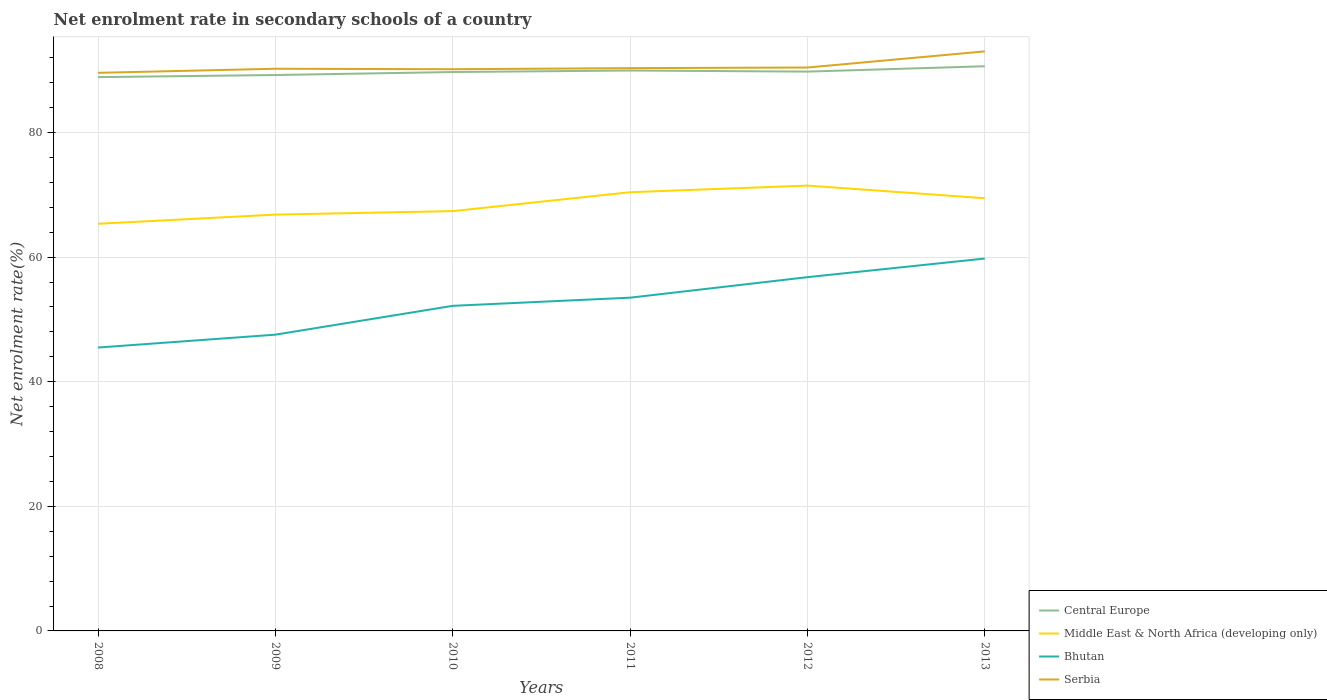Is the number of lines equal to the number of legend labels?
Your response must be concise. Yes. Across all years, what is the maximum net enrolment rate in secondary schools in Serbia?
Make the answer very short. 89.59. What is the total net enrolment rate in secondary schools in Serbia in the graph?
Offer a terse response. -0.58. What is the difference between the highest and the second highest net enrolment rate in secondary schools in Bhutan?
Your answer should be very brief. 14.29. Is the net enrolment rate in secondary schools in Middle East & North Africa (developing only) strictly greater than the net enrolment rate in secondary schools in Central Europe over the years?
Keep it short and to the point. Yes. How many years are there in the graph?
Give a very brief answer. 6. Are the values on the major ticks of Y-axis written in scientific E-notation?
Provide a succinct answer. No. Does the graph contain any zero values?
Make the answer very short. No. Does the graph contain grids?
Your answer should be very brief. Yes. Where does the legend appear in the graph?
Make the answer very short. Bottom right. How many legend labels are there?
Ensure brevity in your answer.  4. What is the title of the graph?
Your response must be concise. Net enrolment rate in secondary schools of a country. Does "Sao Tome and Principe" appear as one of the legend labels in the graph?
Make the answer very short. No. What is the label or title of the Y-axis?
Offer a terse response. Net enrolment rate(%). What is the Net enrolment rate(%) of Central Europe in 2008?
Give a very brief answer. 88.9. What is the Net enrolment rate(%) in Middle East & North Africa (developing only) in 2008?
Offer a very short reply. 65.36. What is the Net enrolment rate(%) in Bhutan in 2008?
Make the answer very short. 45.49. What is the Net enrolment rate(%) of Serbia in 2008?
Offer a terse response. 89.59. What is the Net enrolment rate(%) of Central Europe in 2009?
Provide a succinct answer. 89.23. What is the Net enrolment rate(%) of Middle East & North Africa (developing only) in 2009?
Make the answer very short. 66.83. What is the Net enrolment rate(%) in Bhutan in 2009?
Offer a terse response. 47.56. What is the Net enrolment rate(%) of Serbia in 2009?
Your answer should be very brief. 90.24. What is the Net enrolment rate(%) of Central Europe in 2010?
Provide a short and direct response. 89.71. What is the Net enrolment rate(%) of Middle East & North Africa (developing only) in 2010?
Make the answer very short. 67.39. What is the Net enrolment rate(%) of Bhutan in 2010?
Your answer should be compact. 52.19. What is the Net enrolment rate(%) in Serbia in 2010?
Offer a very short reply. 90.17. What is the Net enrolment rate(%) in Central Europe in 2011?
Ensure brevity in your answer.  89.96. What is the Net enrolment rate(%) in Middle East & North Africa (developing only) in 2011?
Your answer should be compact. 70.42. What is the Net enrolment rate(%) of Bhutan in 2011?
Keep it short and to the point. 53.49. What is the Net enrolment rate(%) of Serbia in 2011?
Ensure brevity in your answer.  90.34. What is the Net enrolment rate(%) in Central Europe in 2012?
Offer a terse response. 89.78. What is the Net enrolment rate(%) of Middle East & North Africa (developing only) in 2012?
Offer a terse response. 71.49. What is the Net enrolment rate(%) of Bhutan in 2012?
Offer a terse response. 56.79. What is the Net enrolment rate(%) of Serbia in 2012?
Give a very brief answer. 90.44. What is the Net enrolment rate(%) of Central Europe in 2013?
Provide a succinct answer. 90.64. What is the Net enrolment rate(%) of Middle East & North Africa (developing only) in 2013?
Make the answer very short. 69.46. What is the Net enrolment rate(%) of Bhutan in 2013?
Your response must be concise. 59.78. What is the Net enrolment rate(%) in Serbia in 2013?
Your response must be concise. 93.03. Across all years, what is the maximum Net enrolment rate(%) in Central Europe?
Ensure brevity in your answer.  90.64. Across all years, what is the maximum Net enrolment rate(%) in Middle East & North Africa (developing only)?
Offer a very short reply. 71.49. Across all years, what is the maximum Net enrolment rate(%) in Bhutan?
Offer a very short reply. 59.78. Across all years, what is the maximum Net enrolment rate(%) of Serbia?
Make the answer very short. 93.03. Across all years, what is the minimum Net enrolment rate(%) in Central Europe?
Ensure brevity in your answer.  88.9. Across all years, what is the minimum Net enrolment rate(%) in Middle East & North Africa (developing only)?
Your response must be concise. 65.36. Across all years, what is the minimum Net enrolment rate(%) in Bhutan?
Your response must be concise. 45.49. Across all years, what is the minimum Net enrolment rate(%) in Serbia?
Offer a terse response. 89.59. What is the total Net enrolment rate(%) in Central Europe in the graph?
Provide a short and direct response. 538.23. What is the total Net enrolment rate(%) in Middle East & North Africa (developing only) in the graph?
Ensure brevity in your answer.  410.94. What is the total Net enrolment rate(%) in Bhutan in the graph?
Keep it short and to the point. 315.29. What is the total Net enrolment rate(%) of Serbia in the graph?
Make the answer very short. 543.8. What is the difference between the Net enrolment rate(%) of Central Europe in 2008 and that in 2009?
Ensure brevity in your answer.  -0.34. What is the difference between the Net enrolment rate(%) in Middle East & North Africa (developing only) in 2008 and that in 2009?
Provide a succinct answer. -1.47. What is the difference between the Net enrolment rate(%) of Bhutan in 2008 and that in 2009?
Provide a succinct answer. -2.07. What is the difference between the Net enrolment rate(%) of Serbia in 2008 and that in 2009?
Provide a short and direct response. -0.65. What is the difference between the Net enrolment rate(%) of Central Europe in 2008 and that in 2010?
Your response must be concise. -0.82. What is the difference between the Net enrolment rate(%) of Middle East & North Africa (developing only) in 2008 and that in 2010?
Give a very brief answer. -2.03. What is the difference between the Net enrolment rate(%) in Bhutan in 2008 and that in 2010?
Your response must be concise. -6.7. What is the difference between the Net enrolment rate(%) of Serbia in 2008 and that in 2010?
Give a very brief answer. -0.58. What is the difference between the Net enrolment rate(%) in Central Europe in 2008 and that in 2011?
Offer a very short reply. -1.06. What is the difference between the Net enrolment rate(%) in Middle East & North Africa (developing only) in 2008 and that in 2011?
Give a very brief answer. -5.07. What is the difference between the Net enrolment rate(%) in Bhutan in 2008 and that in 2011?
Offer a very short reply. -8. What is the difference between the Net enrolment rate(%) in Serbia in 2008 and that in 2011?
Make the answer very short. -0.75. What is the difference between the Net enrolment rate(%) of Central Europe in 2008 and that in 2012?
Your answer should be compact. -0.89. What is the difference between the Net enrolment rate(%) in Middle East & North Africa (developing only) in 2008 and that in 2012?
Ensure brevity in your answer.  -6.13. What is the difference between the Net enrolment rate(%) of Bhutan in 2008 and that in 2012?
Provide a short and direct response. -11.3. What is the difference between the Net enrolment rate(%) in Serbia in 2008 and that in 2012?
Keep it short and to the point. -0.85. What is the difference between the Net enrolment rate(%) in Central Europe in 2008 and that in 2013?
Offer a very short reply. -1.75. What is the difference between the Net enrolment rate(%) of Middle East & North Africa (developing only) in 2008 and that in 2013?
Provide a short and direct response. -4.1. What is the difference between the Net enrolment rate(%) in Bhutan in 2008 and that in 2013?
Your response must be concise. -14.29. What is the difference between the Net enrolment rate(%) in Serbia in 2008 and that in 2013?
Make the answer very short. -3.44. What is the difference between the Net enrolment rate(%) of Central Europe in 2009 and that in 2010?
Your answer should be very brief. -0.48. What is the difference between the Net enrolment rate(%) of Middle East & North Africa (developing only) in 2009 and that in 2010?
Ensure brevity in your answer.  -0.56. What is the difference between the Net enrolment rate(%) in Bhutan in 2009 and that in 2010?
Give a very brief answer. -4.63. What is the difference between the Net enrolment rate(%) in Serbia in 2009 and that in 2010?
Keep it short and to the point. 0.07. What is the difference between the Net enrolment rate(%) of Central Europe in 2009 and that in 2011?
Provide a succinct answer. -0.72. What is the difference between the Net enrolment rate(%) in Middle East & North Africa (developing only) in 2009 and that in 2011?
Your answer should be very brief. -3.6. What is the difference between the Net enrolment rate(%) in Bhutan in 2009 and that in 2011?
Offer a very short reply. -5.94. What is the difference between the Net enrolment rate(%) in Serbia in 2009 and that in 2011?
Ensure brevity in your answer.  -0.1. What is the difference between the Net enrolment rate(%) in Central Europe in 2009 and that in 2012?
Your response must be concise. -0.55. What is the difference between the Net enrolment rate(%) in Middle East & North Africa (developing only) in 2009 and that in 2012?
Ensure brevity in your answer.  -4.66. What is the difference between the Net enrolment rate(%) in Bhutan in 2009 and that in 2012?
Make the answer very short. -9.23. What is the difference between the Net enrolment rate(%) in Serbia in 2009 and that in 2012?
Your response must be concise. -0.2. What is the difference between the Net enrolment rate(%) in Central Europe in 2009 and that in 2013?
Your answer should be very brief. -1.41. What is the difference between the Net enrolment rate(%) in Middle East & North Africa (developing only) in 2009 and that in 2013?
Make the answer very short. -2.63. What is the difference between the Net enrolment rate(%) in Bhutan in 2009 and that in 2013?
Make the answer very short. -12.22. What is the difference between the Net enrolment rate(%) in Serbia in 2009 and that in 2013?
Make the answer very short. -2.79. What is the difference between the Net enrolment rate(%) in Central Europe in 2010 and that in 2011?
Your response must be concise. -0.24. What is the difference between the Net enrolment rate(%) in Middle East & North Africa (developing only) in 2010 and that in 2011?
Provide a short and direct response. -3.03. What is the difference between the Net enrolment rate(%) of Bhutan in 2010 and that in 2011?
Your answer should be very brief. -1.31. What is the difference between the Net enrolment rate(%) of Serbia in 2010 and that in 2011?
Provide a short and direct response. -0.17. What is the difference between the Net enrolment rate(%) in Central Europe in 2010 and that in 2012?
Provide a short and direct response. -0.07. What is the difference between the Net enrolment rate(%) of Middle East & North Africa (developing only) in 2010 and that in 2012?
Give a very brief answer. -4.1. What is the difference between the Net enrolment rate(%) in Bhutan in 2010 and that in 2012?
Provide a short and direct response. -4.6. What is the difference between the Net enrolment rate(%) of Serbia in 2010 and that in 2012?
Your answer should be very brief. -0.27. What is the difference between the Net enrolment rate(%) in Central Europe in 2010 and that in 2013?
Your response must be concise. -0.93. What is the difference between the Net enrolment rate(%) in Middle East & North Africa (developing only) in 2010 and that in 2013?
Offer a terse response. -2.07. What is the difference between the Net enrolment rate(%) of Bhutan in 2010 and that in 2013?
Your answer should be very brief. -7.59. What is the difference between the Net enrolment rate(%) in Serbia in 2010 and that in 2013?
Make the answer very short. -2.86. What is the difference between the Net enrolment rate(%) in Central Europe in 2011 and that in 2012?
Keep it short and to the point. 0.18. What is the difference between the Net enrolment rate(%) in Middle East & North Africa (developing only) in 2011 and that in 2012?
Provide a short and direct response. -1.07. What is the difference between the Net enrolment rate(%) in Bhutan in 2011 and that in 2012?
Your response must be concise. -3.29. What is the difference between the Net enrolment rate(%) in Central Europe in 2011 and that in 2013?
Your answer should be compact. -0.68. What is the difference between the Net enrolment rate(%) in Bhutan in 2011 and that in 2013?
Make the answer very short. -6.28. What is the difference between the Net enrolment rate(%) in Serbia in 2011 and that in 2013?
Provide a short and direct response. -2.69. What is the difference between the Net enrolment rate(%) in Central Europe in 2012 and that in 2013?
Offer a terse response. -0.86. What is the difference between the Net enrolment rate(%) in Middle East & North Africa (developing only) in 2012 and that in 2013?
Keep it short and to the point. 2.03. What is the difference between the Net enrolment rate(%) in Bhutan in 2012 and that in 2013?
Your answer should be compact. -2.99. What is the difference between the Net enrolment rate(%) in Serbia in 2012 and that in 2013?
Offer a terse response. -2.59. What is the difference between the Net enrolment rate(%) of Central Europe in 2008 and the Net enrolment rate(%) of Middle East & North Africa (developing only) in 2009?
Ensure brevity in your answer.  22.07. What is the difference between the Net enrolment rate(%) in Central Europe in 2008 and the Net enrolment rate(%) in Bhutan in 2009?
Give a very brief answer. 41.34. What is the difference between the Net enrolment rate(%) of Central Europe in 2008 and the Net enrolment rate(%) of Serbia in 2009?
Keep it short and to the point. -1.35. What is the difference between the Net enrolment rate(%) of Middle East & North Africa (developing only) in 2008 and the Net enrolment rate(%) of Bhutan in 2009?
Ensure brevity in your answer.  17.8. What is the difference between the Net enrolment rate(%) in Middle East & North Africa (developing only) in 2008 and the Net enrolment rate(%) in Serbia in 2009?
Provide a succinct answer. -24.89. What is the difference between the Net enrolment rate(%) of Bhutan in 2008 and the Net enrolment rate(%) of Serbia in 2009?
Ensure brevity in your answer.  -44.75. What is the difference between the Net enrolment rate(%) of Central Europe in 2008 and the Net enrolment rate(%) of Middle East & North Africa (developing only) in 2010?
Keep it short and to the point. 21.51. What is the difference between the Net enrolment rate(%) in Central Europe in 2008 and the Net enrolment rate(%) in Bhutan in 2010?
Keep it short and to the point. 36.71. What is the difference between the Net enrolment rate(%) in Central Europe in 2008 and the Net enrolment rate(%) in Serbia in 2010?
Give a very brief answer. -1.27. What is the difference between the Net enrolment rate(%) in Middle East & North Africa (developing only) in 2008 and the Net enrolment rate(%) in Bhutan in 2010?
Offer a terse response. 13.17. What is the difference between the Net enrolment rate(%) in Middle East & North Africa (developing only) in 2008 and the Net enrolment rate(%) in Serbia in 2010?
Offer a very short reply. -24.81. What is the difference between the Net enrolment rate(%) in Bhutan in 2008 and the Net enrolment rate(%) in Serbia in 2010?
Your answer should be compact. -44.68. What is the difference between the Net enrolment rate(%) in Central Europe in 2008 and the Net enrolment rate(%) in Middle East & North Africa (developing only) in 2011?
Your answer should be compact. 18.47. What is the difference between the Net enrolment rate(%) of Central Europe in 2008 and the Net enrolment rate(%) of Bhutan in 2011?
Make the answer very short. 35.4. What is the difference between the Net enrolment rate(%) of Central Europe in 2008 and the Net enrolment rate(%) of Serbia in 2011?
Provide a short and direct response. -1.44. What is the difference between the Net enrolment rate(%) of Middle East & North Africa (developing only) in 2008 and the Net enrolment rate(%) of Bhutan in 2011?
Your response must be concise. 11.86. What is the difference between the Net enrolment rate(%) in Middle East & North Africa (developing only) in 2008 and the Net enrolment rate(%) in Serbia in 2011?
Ensure brevity in your answer.  -24.98. What is the difference between the Net enrolment rate(%) of Bhutan in 2008 and the Net enrolment rate(%) of Serbia in 2011?
Give a very brief answer. -44.85. What is the difference between the Net enrolment rate(%) in Central Europe in 2008 and the Net enrolment rate(%) in Middle East & North Africa (developing only) in 2012?
Provide a short and direct response. 17.41. What is the difference between the Net enrolment rate(%) of Central Europe in 2008 and the Net enrolment rate(%) of Bhutan in 2012?
Your answer should be compact. 32.11. What is the difference between the Net enrolment rate(%) in Central Europe in 2008 and the Net enrolment rate(%) in Serbia in 2012?
Provide a succinct answer. -1.54. What is the difference between the Net enrolment rate(%) of Middle East & North Africa (developing only) in 2008 and the Net enrolment rate(%) of Bhutan in 2012?
Provide a succinct answer. 8.57. What is the difference between the Net enrolment rate(%) in Middle East & North Africa (developing only) in 2008 and the Net enrolment rate(%) in Serbia in 2012?
Provide a short and direct response. -25.08. What is the difference between the Net enrolment rate(%) in Bhutan in 2008 and the Net enrolment rate(%) in Serbia in 2012?
Keep it short and to the point. -44.95. What is the difference between the Net enrolment rate(%) in Central Europe in 2008 and the Net enrolment rate(%) in Middle East & North Africa (developing only) in 2013?
Your answer should be compact. 19.44. What is the difference between the Net enrolment rate(%) in Central Europe in 2008 and the Net enrolment rate(%) in Bhutan in 2013?
Offer a terse response. 29.12. What is the difference between the Net enrolment rate(%) of Central Europe in 2008 and the Net enrolment rate(%) of Serbia in 2013?
Your answer should be compact. -4.13. What is the difference between the Net enrolment rate(%) of Middle East & North Africa (developing only) in 2008 and the Net enrolment rate(%) of Bhutan in 2013?
Offer a very short reply. 5.58. What is the difference between the Net enrolment rate(%) in Middle East & North Africa (developing only) in 2008 and the Net enrolment rate(%) in Serbia in 2013?
Offer a terse response. -27.67. What is the difference between the Net enrolment rate(%) of Bhutan in 2008 and the Net enrolment rate(%) of Serbia in 2013?
Make the answer very short. -47.54. What is the difference between the Net enrolment rate(%) in Central Europe in 2009 and the Net enrolment rate(%) in Middle East & North Africa (developing only) in 2010?
Provide a succinct answer. 21.85. What is the difference between the Net enrolment rate(%) of Central Europe in 2009 and the Net enrolment rate(%) of Bhutan in 2010?
Make the answer very short. 37.05. What is the difference between the Net enrolment rate(%) in Central Europe in 2009 and the Net enrolment rate(%) in Serbia in 2010?
Your answer should be compact. -0.93. What is the difference between the Net enrolment rate(%) of Middle East & North Africa (developing only) in 2009 and the Net enrolment rate(%) of Bhutan in 2010?
Ensure brevity in your answer.  14.64. What is the difference between the Net enrolment rate(%) of Middle East & North Africa (developing only) in 2009 and the Net enrolment rate(%) of Serbia in 2010?
Provide a succinct answer. -23.34. What is the difference between the Net enrolment rate(%) in Bhutan in 2009 and the Net enrolment rate(%) in Serbia in 2010?
Provide a short and direct response. -42.61. What is the difference between the Net enrolment rate(%) of Central Europe in 2009 and the Net enrolment rate(%) of Middle East & North Africa (developing only) in 2011?
Give a very brief answer. 18.81. What is the difference between the Net enrolment rate(%) in Central Europe in 2009 and the Net enrolment rate(%) in Bhutan in 2011?
Provide a short and direct response. 35.74. What is the difference between the Net enrolment rate(%) in Central Europe in 2009 and the Net enrolment rate(%) in Serbia in 2011?
Ensure brevity in your answer.  -1.1. What is the difference between the Net enrolment rate(%) in Middle East & North Africa (developing only) in 2009 and the Net enrolment rate(%) in Bhutan in 2011?
Make the answer very short. 13.33. What is the difference between the Net enrolment rate(%) in Middle East & North Africa (developing only) in 2009 and the Net enrolment rate(%) in Serbia in 2011?
Give a very brief answer. -23.51. What is the difference between the Net enrolment rate(%) in Bhutan in 2009 and the Net enrolment rate(%) in Serbia in 2011?
Provide a short and direct response. -42.78. What is the difference between the Net enrolment rate(%) of Central Europe in 2009 and the Net enrolment rate(%) of Middle East & North Africa (developing only) in 2012?
Your answer should be very brief. 17.75. What is the difference between the Net enrolment rate(%) of Central Europe in 2009 and the Net enrolment rate(%) of Bhutan in 2012?
Make the answer very short. 32.45. What is the difference between the Net enrolment rate(%) in Central Europe in 2009 and the Net enrolment rate(%) in Serbia in 2012?
Offer a very short reply. -1.2. What is the difference between the Net enrolment rate(%) in Middle East & North Africa (developing only) in 2009 and the Net enrolment rate(%) in Bhutan in 2012?
Your answer should be compact. 10.04. What is the difference between the Net enrolment rate(%) in Middle East & North Africa (developing only) in 2009 and the Net enrolment rate(%) in Serbia in 2012?
Provide a short and direct response. -23.61. What is the difference between the Net enrolment rate(%) of Bhutan in 2009 and the Net enrolment rate(%) of Serbia in 2012?
Your response must be concise. -42.88. What is the difference between the Net enrolment rate(%) of Central Europe in 2009 and the Net enrolment rate(%) of Middle East & North Africa (developing only) in 2013?
Your answer should be compact. 19.78. What is the difference between the Net enrolment rate(%) of Central Europe in 2009 and the Net enrolment rate(%) of Bhutan in 2013?
Your answer should be very brief. 29.46. What is the difference between the Net enrolment rate(%) of Central Europe in 2009 and the Net enrolment rate(%) of Serbia in 2013?
Make the answer very short. -3.79. What is the difference between the Net enrolment rate(%) in Middle East & North Africa (developing only) in 2009 and the Net enrolment rate(%) in Bhutan in 2013?
Offer a very short reply. 7.05. What is the difference between the Net enrolment rate(%) in Middle East & North Africa (developing only) in 2009 and the Net enrolment rate(%) in Serbia in 2013?
Your answer should be very brief. -26.2. What is the difference between the Net enrolment rate(%) of Bhutan in 2009 and the Net enrolment rate(%) of Serbia in 2013?
Offer a very short reply. -45.47. What is the difference between the Net enrolment rate(%) of Central Europe in 2010 and the Net enrolment rate(%) of Middle East & North Africa (developing only) in 2011?
Ensure brevity in your answer.  19.29. What is the difference between the Net enrolment rate(%) of Central Europe in 2010 and the Net enrolment rate(%) of Bhutan in 2011?
Your answer should be very brief. 36.22. What is the difference between the Net enrolment rate(%) of Central Europe in 2010 and the Net enrolment rate(%) of Serbia in 2011?
Provide a short and direct response. -0.62. What is the difference between the Net enrolment rate(%) of Middle East & North Africa (developing only) in 2010 and the Net enrolment rate(%) of Bhutan in 2011?
Give a very brief answer. 13.89. What is the difference between the Net enrolment rate(%) of Middle East & North Africa (developing only) in 2010 and the Net enrolment rate(%) of Serbia in 2011?
Your response must be concise. -22.95. What is the difference between the Net enrolment rate(%) in Bhutan in 2010 and the Net enrolment rate(%) in Serbia in 2011?
Keep it short and to the point. -38.15. What is the difference between the Net enrolment rate(%) in Central Europe in 2010 and the Net enrolment rate(%) in Middle East & North Africa (developing only) in 2012?
Your answer should be very brief. 18.23. What is the difference between the Net enrolment rate(%) in Central Europe in 2010 and the Net enrolment rate(%) in Bhutan in 2012?
Provide a succinct answer. 32.93. What is the difference between the Net enrolment rate(%) of Central Europe in 2010 and the Net enrolment rate(%) of Serbia in 2012?
Provide a short and direct response. -0.72. What is the difference between the Net enrolment rate(%) in Middle East & North Africa (developing only) in 2010 and the Net enrolment rate(%) in Bhutan in 2012?
Keep it short and to the point. 10.6. What is the difference between the Net enrolment rate(%) in Middle East & North Africa (developing only) in 2010 and the Net enrolment rate(%) in Serbia in 2012?
Ensure brevity in your answer.  -23.05. What is the difference between the Net enrolment rate(%) in Bhutan in 2010 and the Net enrolment rate(%) in Serbia in 2012?
Provide a succinct answer. -38.25. What is the difference between the Net enrolment rate(%) of Central Europe in 2010 and the Net enrolment rate(%) of Middle East & North Africa (developing only) in 2013?
Provide a short and direct response. 20.26. What is the difference between the Net enrolment rate(%) of Central Europe in 2010 and the Net enrolment rate(%) of Bhutan in 2013?
Make the answer very short. 29.94. What is the difference between the Net enrolment rate(%) of Central Europe in 2010 and the Net enrolment rate(%) of Serbia in 2013?
Give a very brief answer. -3.31. What is the difference between the Net enrolment rate(%) of Middle East & North Africa (developing only) in 2010 and the Net enrolment rate(%) of Bhutan in 2013?
Ensure brevity in your answer.  7.61. What is the difference between the Net enrolment rate(%) of Middle East & North Africa (developing only) in 2010 and the Net enrolment rate(%) of Serbia in 2013?
Your answer should be very brief. -25.64. What is the difference between the Net enrolment rate(%) of Bhutan in 2010 and the Net enrolment rate(%) of Serbia in 2013?
Your response must be concise. -40.84. What is the difference between the Net enrolment rate(%) in Central Europe in 2011 and the Net enrolment rate(%) in Middle East & North Africa (developing only) in 2012?
Ensure brevity in your answer.  18.47. What is the difference between the Net enrolment rate(%) in Central Europe in 2011 and the Net enrolment rate(%) in Bhutan in 2012?
Your answer should be very brief. 33.17. What is the difference between the Net enrolment rate(%) in Central Europe in 2011 and the Net enrolment rate(%) in Serbia in 2012?
Offer a terse response. -0.48. What is the difference between the Net enrolment rate(%) of Middle East & North Africa (developing only) in 2011 and the Net enrolment rate(%) of Bhutan in 2012?
Offer a very short reply. 13.64. What is the difference between the Net enrolment rate(%) of Middle East & North Africa (developing only) in 2011 and the Net enrolment rate(%) of Serbia in 2012?
Give a very brief answer. -20.02. What is the difference between the Net enrolment rate(%) of Bhutan in 2011 and the Net enrolment rate(%) of Serbia in 2012?
Your answer should be compact. -36.94. What is the difference between the Net enrolment rate(%) of Central Europe in 2011 and the Net enrolment rate(%) of Middle East & North Africa (developing only) in 2013?
Give a very brief answer. 20.5. What is the difference between the Net enrolment rate(%) in Central Europe in 2011 and the Net enrolment rate(%) in Bhutan in 2013?
Your response must be concise. 30.18. What is the difference between the Net enrolment rate(%) of Central Europe in 2011 and the Net enrolment rate(%) of Serbia in 2013?
Your answer should be compact. -3.07. What is the difference between the Net enrolment rate(%) in Middle East & North Africa (developing only) in 2011 and the Net enrolment rate(%) in Bhutan in 2013?
Ensure brevity in your answer.  10.65. What is the difference between the Net enrolment rate(%) in Middle East & North Africa (developing only) in 2011 and the Net enrolment rate(%) in Serbia in 2013?
Offer a terse response. -22.61. What is the difference between the Net enrolment rate(%) of Bhutan in 2011 and the Net enrolment rate(%) of Serbia in 2013?
Give a very brief answer. -39.54. What is the difference between the Net enrolment rate(%) of Central Europe in 2012 and the Net enrolment rate(%) of Middle East & North Africa (developing only) in 2013?
Make the answer very short. 20.33. What is the difference between the Net enrolment rate(%) in Central Europe in 2012 and the Net enrolment rate(%) in Bhutan in 2013?
Ensure brevity in your answer.  30.01. What is the difference between the Net enrolment rate(%) of Central Europe in 2012 and the Net enrolment rate(%) of Serbia in 2013?
Provide a short and direct response. -3.25. What is the difference between the Net enrolment rate(%) of Middle East & North Africa (developing only) in 2012 and the Net enrolment rate(%) of Bhutan in 2013?
Ensure brevity in your answer.  11.71. What is the difference between the Net enrolment rate(%) in Middle East & North Africa (developing only) in 2012 and the Net enrolment rate(%) in Serbia in 2013?
Your answer should be compact. -21.54. What is the difference between the Net enrolment rate(%) in Bhutan in 2012 and the Net enrolment rate(%) in Serbia in 2013?
Make the answer very short. -36.24. What is the average Net enrolment rate(%) of Central Europe per year?
Ensure brevity in your answer.  89.7. What is the average Net enrolment rate(%) of Middle East & North Africa (developing only) per year?
Your answer should be compact. 68.49. What is the average Net enrolment rate(%) of Bhutan per year?
Your answer should be very brief. 52.55. What is the average Net enrolment rate(%) of Serbia per year?
Your answer should be very brief. 90.63. In the year 2008, what is the difference between the Net enrolment rate(%) in Central Europe and Net enrolment rate(%) in Middle East & North Africa (developing only)?
Offer a very short reply. 23.54. In the year 2008, what is the difference between the Net enrolment rate(%) in Central Europe and Net enrolment rate(%) in Bhutan?
Your response must be concise. 43.41. In the year 2008, what is the difference between the Net enrolment rate(%) of Central Europe and Net enrolment rate(%) of Serbia?
Ensure brevity in your answer.  -0.69. In the year 2008, what is the difference between the Net enrolment rate(%) of Middle East & North Africa (developing only) and Net enrolment rate(%) of Bhutan?
Give a very brief answer. 19.87. In the year 2008, what is the difference between the Net enrolment rate(%) in Middle East & North Africa (developing only) and Net enrolment rate(%) in Serbia?
Keep it short and to the point. -24.23. In the year 2008, what is the difference between the Net enrolment rate(%) of Bhutan and Net enrolment rate(%) of Serbia?
Offer a very short reply. -44.1. In the year 2009, what is the difference between the Net enrolment rate(%) in Central Europe and Net enrolment rate(%) in Middle East & North Africa (developing only)?
Ensure brevity in your answer.  22.41. In the year 2009, what is the difference between the Net enrolment rate(%) in Central Europe and Net enrolment rate(%) in Bhutan?
Offer a very short reply. 41.68. In the year 2009, what is the difference between the Net enrolment rate(%) in Central Europe and Net enrolment rate(%) in Serbia?
Keep it short and to the point. -1.01. In the year 2009, what is the difference between the Net enrolment rate(%) of Middle East & North Africa (developing only) and Net enrolment rate(%) of Bhutan?
Offer a terse response. 19.27. In the year 2009, what is the difference between the Net enrolment rate(%) of Middle East & North Africa (developing only) and Net enrolment rate(%) of Serbia?
Your response must be concise. -23.41. In the year 2009, what is the difference between the Net enrolment rate(%) in Bhutan and Net enrolment rate(%) in Serbia?
Provide a short and direct response. -42.68. In the year 2010, what is the difference between the Net enrolment rate(%) of Central Europe and Net enrolment rate(%) of Middle East & North Africa (developing only)?
Offer a very short reply. 22.33. In the year 2010, what is the difference between the Net enrolment rate(%) in Central Europe and Net enrolment rate(%) in Bhutan?
Your answer should be very brief. 37.53. In the year 2010, what is the difference between the Net enrolment rate(%) of Central Europe and Net enrolment rate(%) of Serbia?
Keep it short and to the point. -0.45. In the year 2010, what is the difference between the Net enrolment rate(%) of Middle East & North Africa (developing only) and Net enrolment rate(%) of Bhutan?
Give a very brief answer. 15.2. In the year 2010, what is the difference between the Net enrolment rate(%) of Middle East & North Africa (developing only) and Net enrolment rate(%) of Serbia?
Offer a terse response. -22.78. In the year 2010, what is the difference between the Net enrolment rate(%) in Bhutan and Net enrolment rate(%) in Serbia?
Give a very brief answer. -37.98. In the year 2011, what is the difference between the Net enrolment rate(%) of Central Europe and Net enrolment rate(%) of Middle East & North Africa (developing only)?
Keep it short and to the point. 19.54. In the year 2011, what is the difference between the Net enrolment rate(%) in Central Europe and Net enrolment rate(%) in Bhutan?
Your answer should be compact. 36.47. In the year 2011, what is the difference between the Net enrolment rate(%) in Central Europe and Net enrolment rate(%) in Serbia?
Your answer should be compact. -0.38. In the year 2011, what is the difference between the Net enrolment rate(%) of Middle East & North Africa (developing only) and Net enrolment rate(%) of Bhutan?
Your answer should be compact. 16.93. In the year 2011, what is the difference between the Net enrolment rate(%) in Middle East & North Africa (developing only) and Net enrolment rate(%) in Serbia?
Offer a very short reply. -19.92. In the year 2011, what is the difference between the Net enrolment rate(%) in Bhutan and Net enrolment rate(%) in Serbia?
Keep it short and to the point. -36.84. In the year 2012, what is the difference between the Net enrolment rate(%) of Central Europe and Net enrolment rate(%) of Middle East & North Africa (developing only)?
Give a very brief answer. 18.29. In the year 2012, what is the difference between the Net enrolment rate(%) of Central Europe and Net enrolment rate(%) of Bhutan?
Offer a very short reply. 33. In the year 2012, what is the difference between the Net enrolment rate(%) of Central Europe and Net enrolment rate(%) of Serbia?
Offer a very short reply. -0.66. In the year 2012, what is the difference between the Net enrolment rate(%) in Middle East & North Africa (developing only) and Net enrolment rate(%) in Bhutan?
Provide a succinct answer. 14.7. In the year 2012, what is the difference between the Net enrolment rate(%) of Middle East & North Africa (developing only) and Net enrolment rate(%) of Serbia?
Give a very brief answer. -18.95. In the year 2012, what is the difference between the Net enrolment rate(%) of Bhutan and Net enrolment rate(%) of Serbia?
Your answer should be very brief. -33.65. In the year 2013, what is the difference between the Net enrolment rate(%) of Central Europe and Net enrolment rate(%) of Middle East & North Africa (developing only)?
Your response must be concise. 21.19. In the year 2013, what is the difference between the Net enrolment rate(%) in Central Europe and Net enrolment rate(%) in Bhutan?
Provide a succinct answer. 30.87. In the year 2013, what is the difference between the Net enrolment rate(%) in Central Europe and Net enrolment rate(%) in Serbia?
Give a very brief answer. -2.39. In the year 2013, what is the difference between the Net enrolment rate(%) in Middle East & North Africa (developing only) and Net enrolment rate(%) in Bhutan?
Provide a succinct answer. 9.68. In the year 2013, what is the difference between the Net enrolment rate(%) in Middle East & North Africa (developing only) and Net enrolment rate(%) in Serbia?
Offer a terse response. -23.57. In the year 2013, what is the difference between the Net enrolment rate(%) in Bhutan and Net enrolment rate(%) in Serbia?
Keep it short and to the point. -33.25. What is the ratio of the Net enrolment rate(%) of Bhutan in 2008 to that in 2009?
Provide a short and direct response. 0.96. What is the ratio of the Net enrolment rate(%) in Central Europe in 2008 to that in 2010?
Offer a terse response. 0.99. What is the ratio of the Net enrolment rate(%) of Middle East & North Africa (developing only) in 2008 to that in 2010?
Your answer should be very brief. 0.97. What is the ratio of the Net enrolment rate(%) of Bhutan in 2008 to that in 2010?
Ensure brevity in your answer.  0.87. What is the ratio of the Net enrolment rate(%) of Middle East & North Africa (developing only) in 2008 to that in 2011?
Provide a short and direct response. 0.93. What is the ratio of the Net enrolment rate(%) of Bhutan in 2008 to that in 2011?
Provide a succinct answer. 0.85. What is the ratio of the Net enrolment rate(%) of Serbia in 2008 to that in 2011?
Offer a very short reply. 0.99. What is the ratio of the Net enrolment rate(%) in Middle East & North Africa (developing only) in 2008 to that in 2012?
Offer a very short reply. 0.91. What is the ratio of the Net enrolment rate(%) of Bhutan in 2008 to that in 2012?
Provide a short and direct response. 0.8. What is the ratio of the Net enrolment rate(%) of Serbia in 2008 to that in 2012?
Provide a short and direct response. 0.99. What is the ratio of the Net enrolment rate(%) in Central Europe in 2008 to that in 2013?
Ensure brevity in your answer.  0.98. What is the ratio of the Net enrolment rate(%) in Middle East & North Africa (developing only) in 2008 to that in 2013?
Your answer should be compact. 0.94. What is the ratio of the Net enrolment rate(%) in Bhutan in 2008 to that in 2013?
Ensure brevity in your answer.  0.76. What is the ratio of the Net enrolment rate(%) in Serbia in 2008 to that in 2013?
Give a very brief answer. 0.96. What is the ratio of the Net enrolment rate(%) in Central Europe in 2009 to that in 2010?
Ensure brevity in your answer.  0.99. What is the ratio of the Net enrolment rate(%) of Bhutan in 2009 to that in 2010?
Your answer should be compact. 0.91. What is the ratio of the Net enrolment rate(%) of Middle East & North Africa (developing only) in 2009 to that in 2011?
Offer a very short reply. 0.95. What is the ratio of the Net enrolment rate(%) in Bhutan in 2009 to that in 2011?
Ensure brevity in your answer.  0.89. What is the ratio of the Net enrolment rate(%) in Middle East & North Africa (developing only) in 2009 to that in 2012?
Your answer should be compact. 0.93. What is the ratio of the Net enrolment rate(%) in Bhutan in 2009 to that in 2012?
Offer a terse response. 0.84. What is the ratio of the Net enrolment rate(%) in Central Europe in 2009 to that in 2013?
Ensure brevity in your answer.  0.98. What is the ratio of the Net enrolment rate(%) of Middle East & North Africa (developing only) in 2009 to that in 2013?
Give a very brief answer. 0.96. What is the ratio of the Net enrolment rate(%) of Bhutan in 2009 to that in 2013?
Give a very brief answer. 0.8. What is the ratio of the Net enrolment rate(%) of Serbia in 2009 to that in 2013?
Your answer should be very brief. 0.97. What is the ratio of the Net enrolment rate(%) of Middle East & North Africa (developing only) in 2010 to that in 2011?
Provide a succinct answer. 0.96. What is the ratio of the Net enrolment rate(%) of Bhutan in 2010 to that in 2011?
Ensure brevity in your answer.  0.98. What is the ratio of the Net enrolment rate(%) of Serbia in 2010 to that in 2011?
Offer a very short reply. 1. What is the ratio of the Net enrolment rate(%) in Central Europe in 2010 to that in 2012?
Keep it short and to the point. 1. What is the ratio of the Net enrolment rate(%) in Middle East & North Africa (developing only) in 2010 to that in 2012?
Ensure brevity in your answer.  0.94. What is the ratio of the Net enrolment rate(%) in Bhutan in 2010 to that in 2012?
Your answer should be very brief. 0.92. What is the ratio of the Net enrolment rate(%) of Middle East & North Africa (developing only) in 2010 to that in 2013?
Ensure brevity in your answer.  0.97. What is the ratio of the Net enrolment rate(%) in Bhutan in 2010 to that in 2013?
Give a very brief answer. 0.87. What is the ratio of the Net enrolment rate(%) in Serbia in 2010 to that in 2013?
Offer a very short reply. 0.97. What is the ratio of the Net enrolment rate(%) in Central Europe in 2011 to that in 2012?
Keep it short and to the point. 1. What is the ratio of the Net enrolment rate(%) of Middle East & North Africa (developing only) in 2011 to that in 2012?
Give a very brief answer. 0.99. What is the ratio of the Net enrolment rate(%) of Bhutan in 2011 to that in 2012?
Offer a very short reply. 0.94. What is the ratio of the Net enrolment rate(%) in Serbia in 2011 to that in 2012?
Ensure brevity in your answer.  1. What is the ratio of the Net enrolment rate(%) in Middle East & North Africa (developing only) in 2011 to that in 2013?
Your answer should be compact. 1.01. What is the ratio of the Net enrolment rate(%) of Bhutan in 2011 to that in 2013?
Ensure brevity in your answer.  0.89. What is the ratio of the Net enrolment rate(%) in Serbia in 2011 to that in 2013?
Ensure brevity in your answer.  0.97. What is the ratio of the Net enrolment rate(%) in Central Europe in 2012 to that in 2013?
Your response must be concise. 0.99. What is the ratio of the Net enrolment rate(%) of Middle East & North Africa (developing only) in 2012 to that in 2013?
Offer a very short reply. 1.03. What is the ratio of the Net enrolment rate(%) in Bhutan in 2012 to that in 2013?
Keep it short and to the point. 0.95. What is the ratio of the Net enrolment rate(%) in Serbia in 2012 to that in 2013?
Your answer should be compact. 0.97. What is the difference between the highest and the second highest Net enrolment rate(%) of Central Europe?
Your response must be concise. 0.68. What is the difference between the highest and the second highest Net enrolment rate(%) of Middle East & North Africa (developing only)?
Offer a very short reply. 1.07. What is the difference between the highest and the second highest Net enrolment rate(%) in Bhutan?
Your response must be concise. 2.99. What is the difference between the highest and the second highest Net enrolment rate(%) of Serbia?
Give a very brief answer. 2.59. What is the difference between the highest and the lowest Net enrolment rate(%) of Central Europe?
Your response must be concise. 1.75. What is the difference between the highest and the lowest Net enrolment rate(%) of Middle East & North Africa (developing only)?
Offer a terse response. 6.13. What is the difference between the highest and the lowest Net enrolment rate(%) of Bhutan?
Provide a short and direct response. 14.29. What is the difference between the highest and the lowest Net enrolment rate(%) of Serbia?
Make the answer very short. 3.44. 